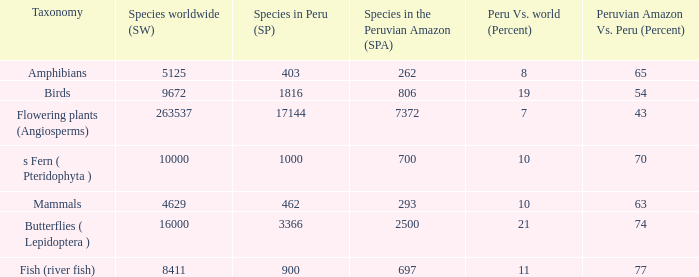What's the maximum peru vs. world (percent) with 9672 species in the world  19.0. 